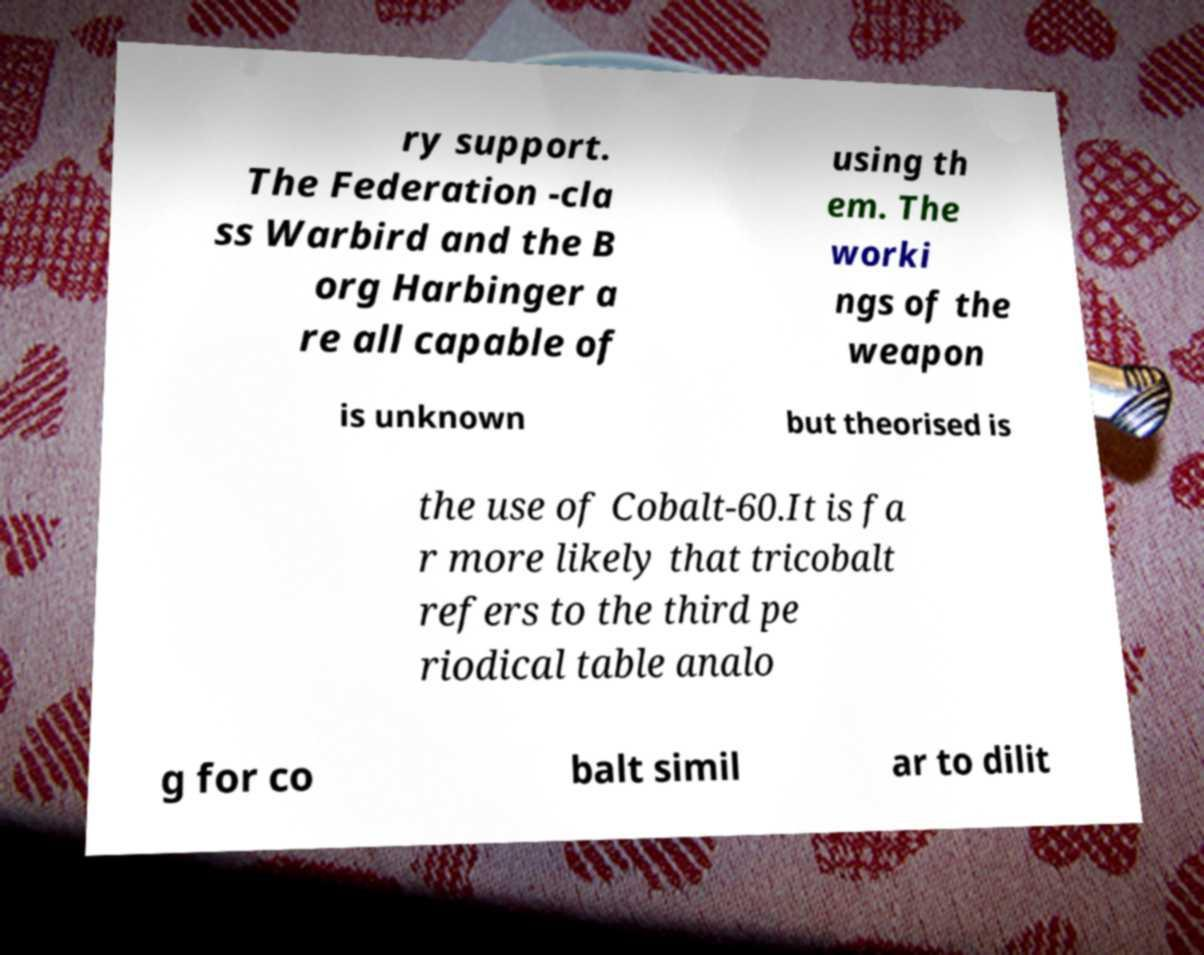Can you accurately transcribe the text from the provided image for me? ry support. The Federation -cla ss Warbird and the B org Harbinger a re all capable of using th em. The worki ngs of the weapon is unknown but theorised is the use of Cobalt-60.It is fa r more likely that tricobalt refers to the third pe riodical table analo g for co balt simil ar to dilit 